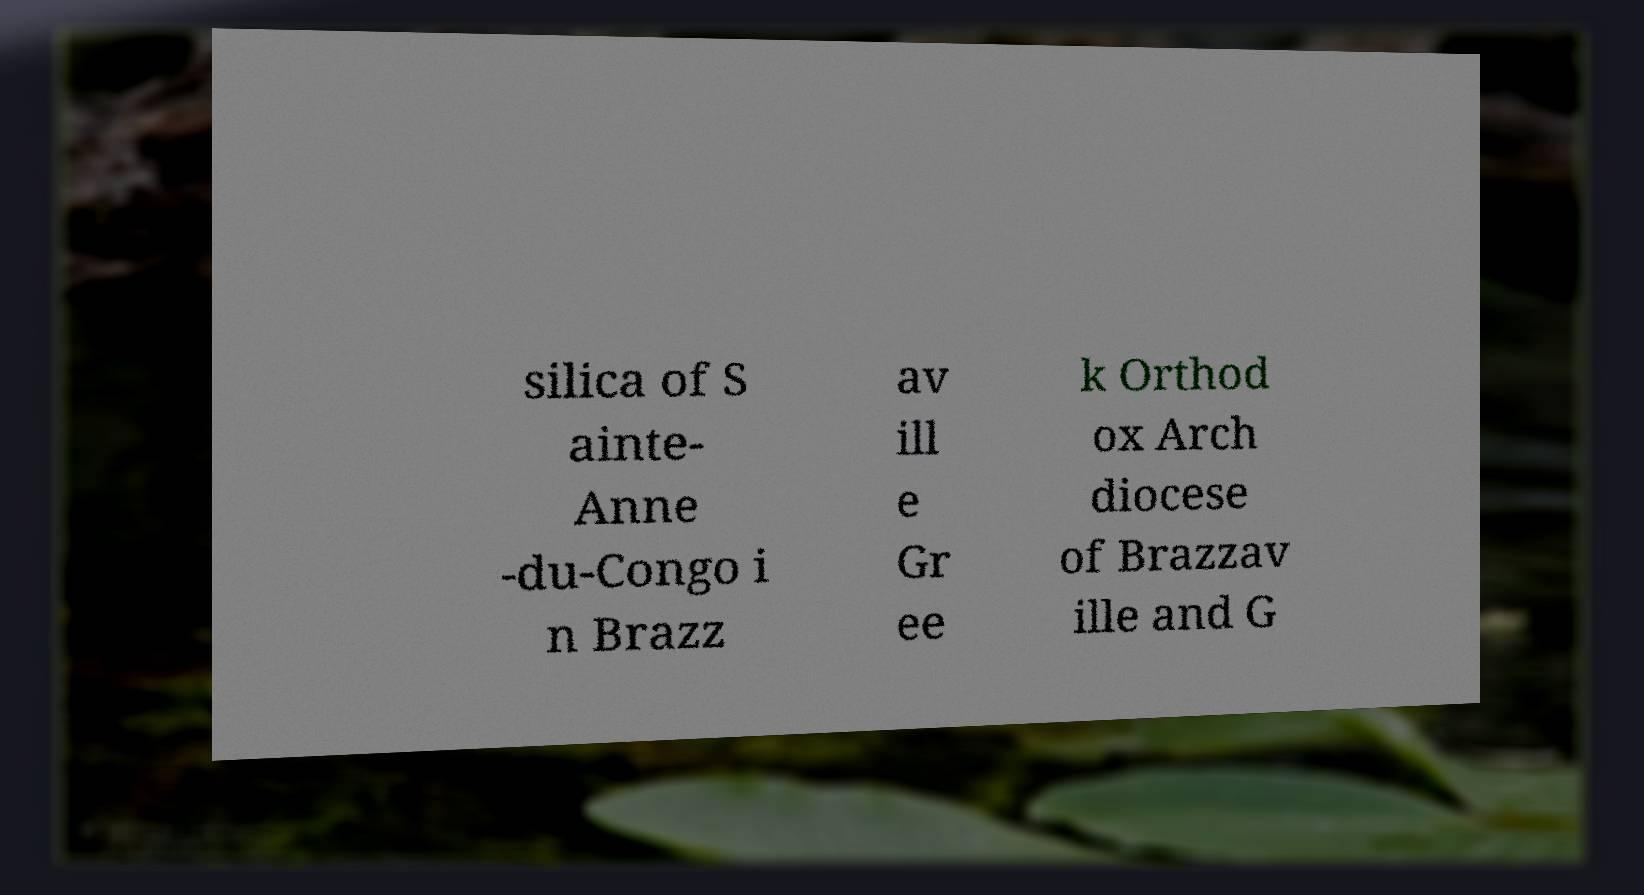Can you read and provide the text displayed in the image?This photo seems to have some interesting text. Can you extract and type it out for me? silica of S ainte- Anne -du-Congo i n Brazz av ill e Gr ee k Orthod ox Arch diocese of Brazzav ille and G 